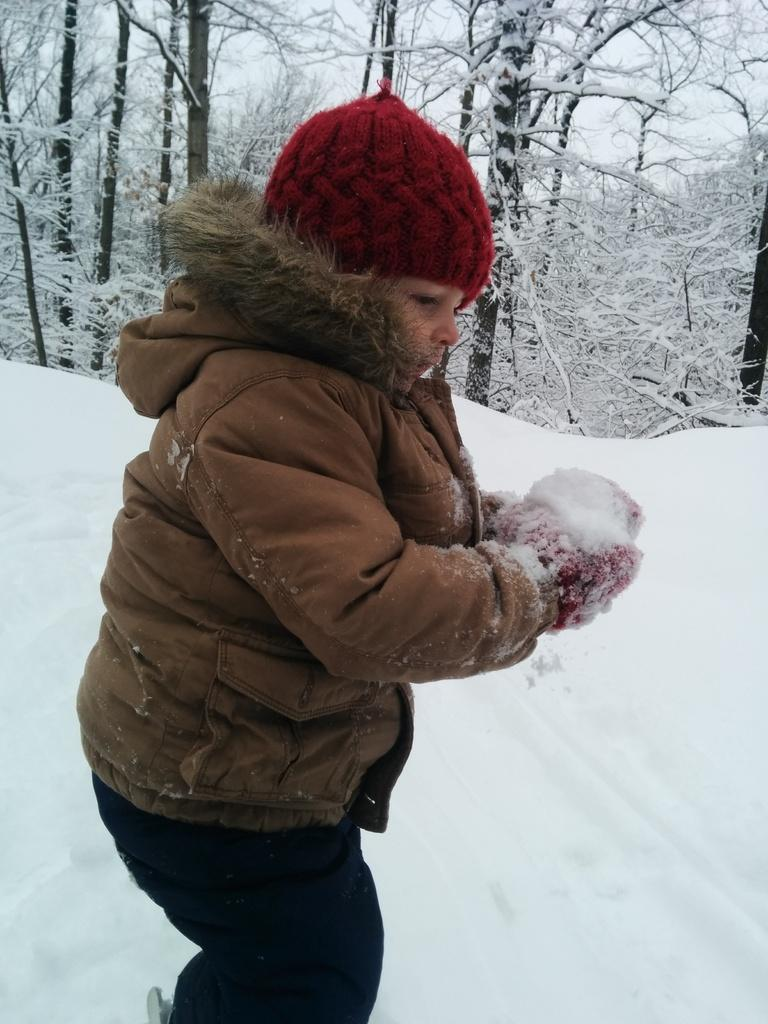What is the main subject of the image? There is a child in the image. What is the child doing in the image? The child is standing on the ground and holding ice. What can be seen in the background of the image? There is a group of trees and the sky is visible in the image. What is the condition of the ground in the image? The ground is covered in snow. What type of minister is present in the image? There is no minister present in the image; it features a child standing on the ground and holding ice. Can you tell me how many chess pieces are visible on the ground in the image? There are no chess pieces visible in the image; it features a child holding ice and a background with trees and snow-covered ground. 